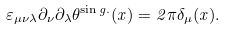<formula> <loc_0><loc_0><loc_500><loc_500>\varepsilon _ { \mu \nu \lambda } \partial _ { \nu } \partial _ { \lambda } \theta ^ { \sin g . } ( x ) = 2 \pi \delta _ { \mu } ( x ) .</formula> 